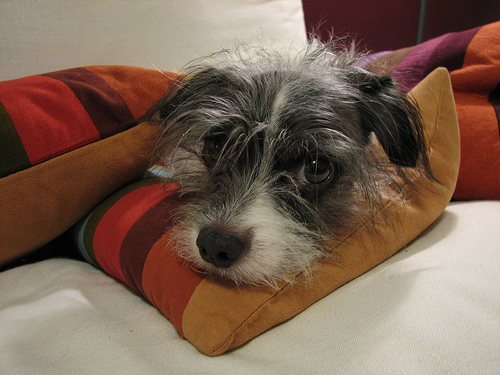<image>
Is the dog on the couch? Yes. Looking at the image, I can see the dog is positioned on top of the couch, with the couch providing support. 